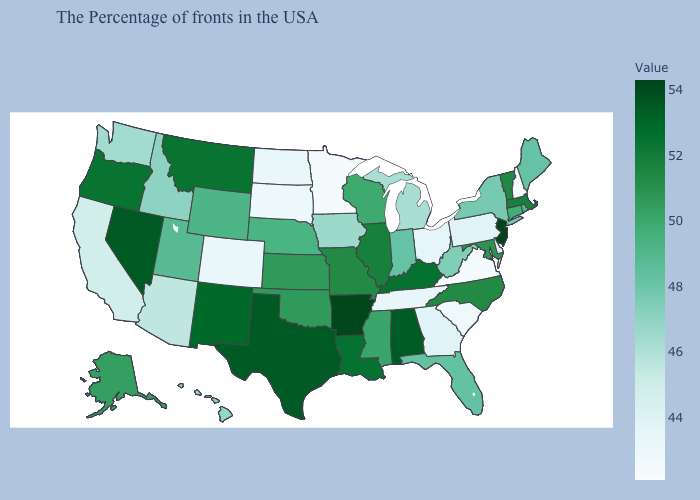Does the map have missing data?
Give a very brief answer. No. Among the states that border Idaho , does Washington have the lowest value?
Give a very brief answer. Yes. Among the states that border Florida , which have the highest value?
Write a very short answer. Alabama. Does Pennsylvania have the lowest value in the USA?
Concise answer only. No. Which states hav the highest value in the MidWest?
Give a very brief answer. Illinois. Does Texas have the lowest value in the South?
Quick response, please. No. Is the legend a continuous bar?
Answer briefly. Yes. Does Georgia have the highest value in the South?
Write a very short answer. No. Does New York have a higher value than Alabama?
Quick response, please. No. Does the map have missing data?
Keep it brief. No. 